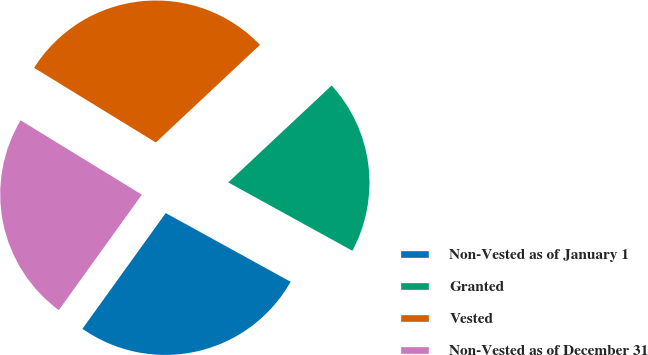Convert chart to OTSL. <chart><loc_0><loc_0><loc_500><loc_500><pie_chart><fcel>Non-Vested as of January 1<fcel>Granted<fcel>Vested<fcel>Non-Vested as of December 31<nl><fcel>26.92%<fcel>19.99%<fcel>29.26%<fcel>23.83%<nl></chart> 